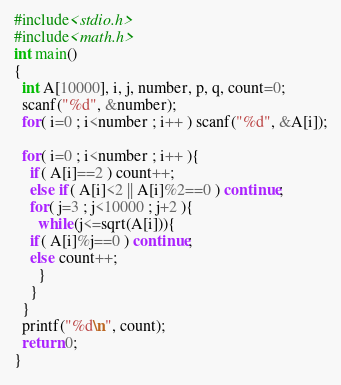Convert code to text. <code><loc_0><loc_0><loc_500><loc_500><_C_>#include<stdio.h>
#include<math.h>
int main()
{
  int A[10000], i, j, number, p, q, count=0;
  scanf("%d", &number);
  for( i=0 ; i<number ; i++ ) scanf("%d", &A[i]);
  
  for( i=0 ; i<number ; i++ ){
    if( A[i]==2 ) count++;
    else if( A[i]<2 || A[i]%2==0 ) continue;
    for( j=3 ; j<10000 ; j+2 ){
      while(j<=sqrt(A[i])){
	if( A[i]%j==0 ) continue;
	else count++;
      }   
    }
  }
  printf("%d\n", count);
  return 0;
}</code> 